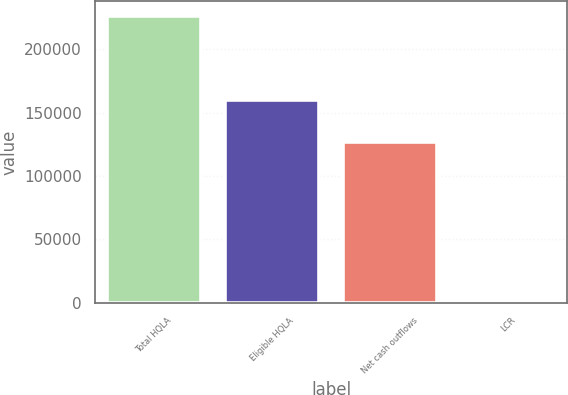Convert chart. <chart><loc_0><loc_0><loc_500><loc_500><bar_chart><fcel>Total HQLA<fcel>Eligible HQLA<fcel>Net cash outflows<fcel>LCR<nl><fcel>226473<fcel>160016<fcel>126511<fcel>127<nl></chart> 